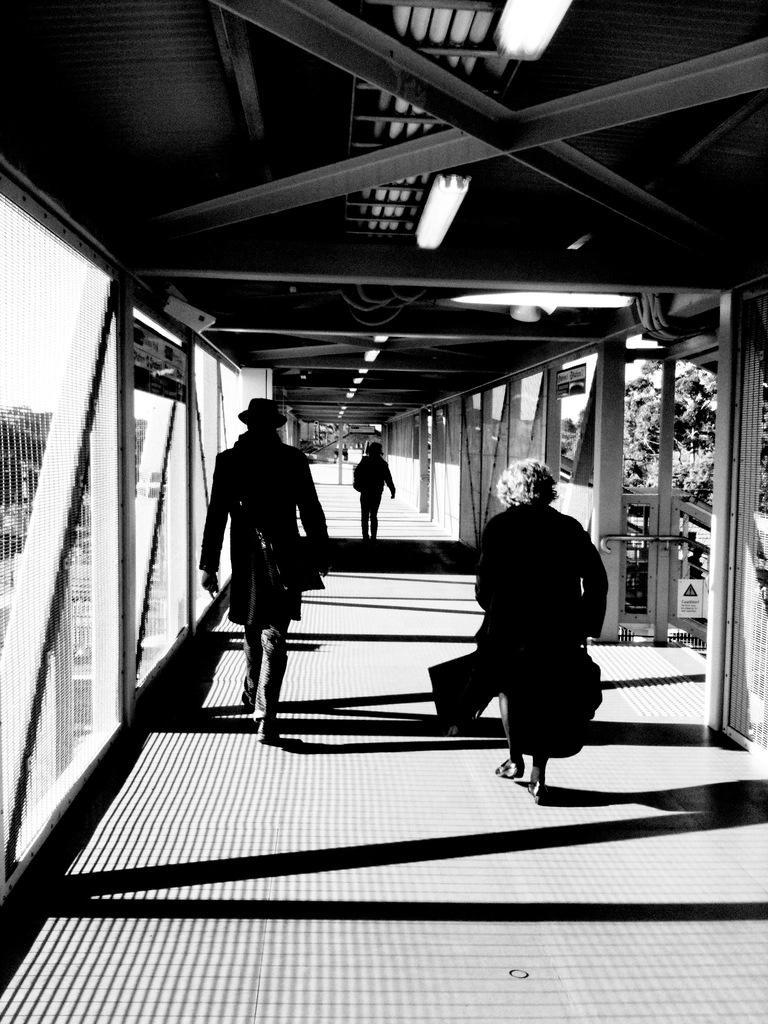Describe this image in one or two sentences. In this image we can see group of persons are walking on the bridge, at above, there are lights, there are trees, here it is in black and white. 